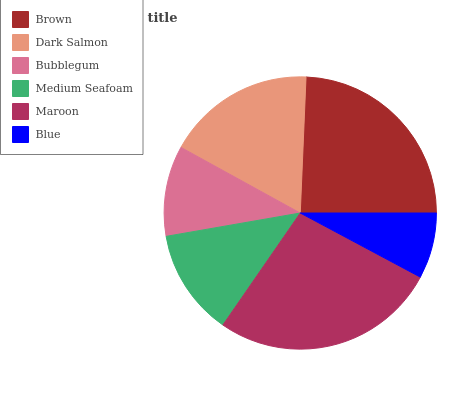Is Blue the minimum?
Answer yes or no. Yes. Is Maroon the maximum?
Answer yes or no. Yes. Is Dark Salmon the minimum?
Answer yes or no. No. Is Dark Salmon the maximum?
Answer yes or no. No. Is Brown greater than Dark Salmon?
Answer yes or no. Yes. Is Dark Salmon less than Brown?
Answer yes or no. Yes. Is Dark Salmon greater than Brown?
Answer yes or no. No. Is Brown less than Dark Salmon?
Answer yes or no. No. Is Dark Salmon the high median?
Answer yes or no. Yes. Is Medium Seafoam the low median?
Answer yes or no. Yes. Is Maroon the high median?
Answer yes or no. No. Is Bubblegum the low median?
Answer yes or no. No. 